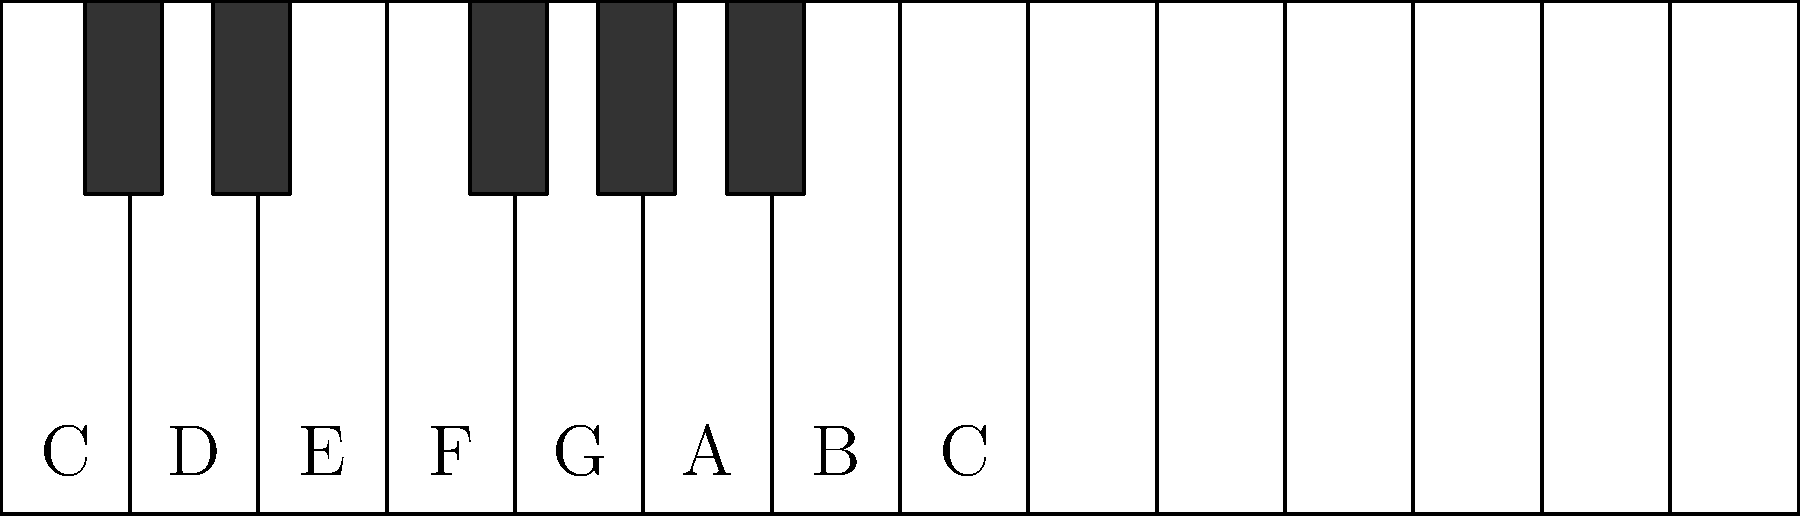In the piano key layout shown above, how many white keys are there between two sets of black keys (from the end of one group to the start of the next)? To answer this question, let's follow these steps:

1. Identify the pattern of black and white keys:
   - Black keys are arranged in groups of 2 and 3 alternately.
   - The white keys fill the spaces between and around the black keys.

2. Locate two sets of black keys:
   - We can see a group of 2 black keys on the left side of the diagram.
   - The next group of 3 black keys starts further to the right.

3. Count the white keys between these two sets:
   - Start counting after the group of 2 black keys.
   - Stop counting before the group of 3 black keys begins.
   - We can see there are 3 white keys in this space.

4. Verify the answer:
   - These 3 white keys correspond to the notes F, G, and A on a piano.
   - This is a consistent pattern on all pianos, regardless of their size or range.

Therefore, there are always 3 white keys between two sets of black keys on a piano.
Answer: 3 white keys 